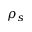<formula> <loc_0><loc_0><loc_500><loc_500>\rho _ { s }</formula> 